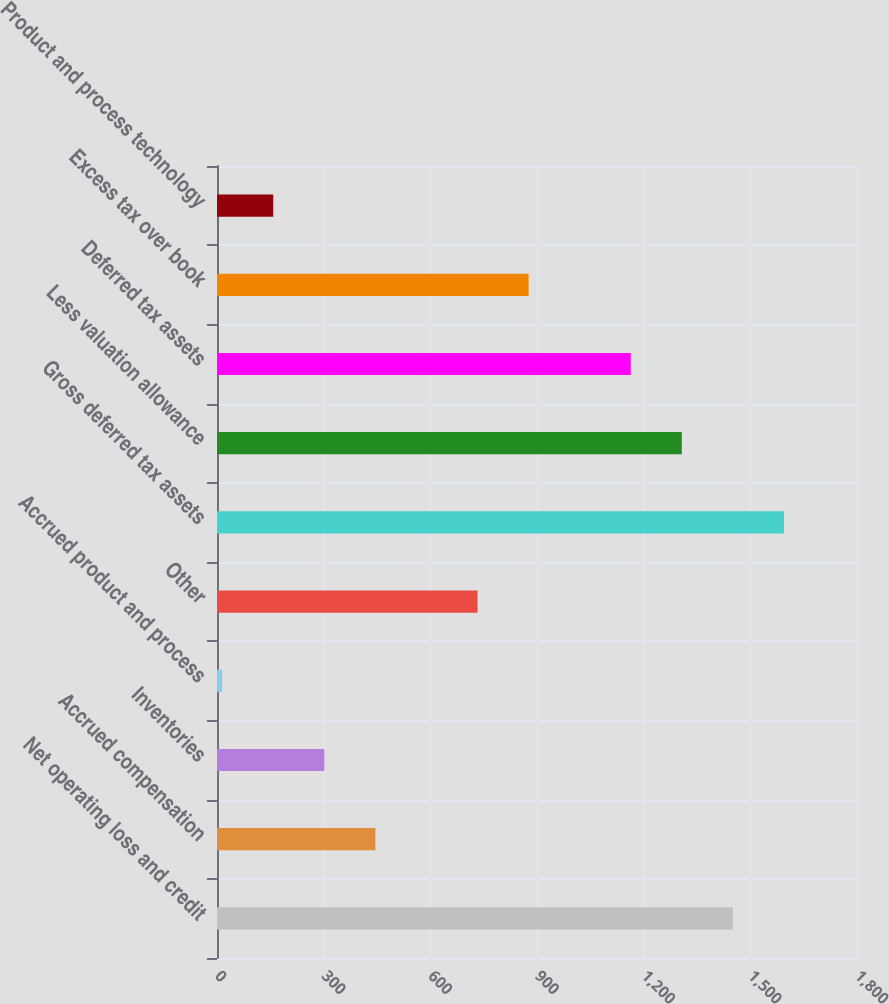Convert chart to OTSL. <chart><loc_0><loc_0><loc_500><loc_500><bar_chart><fcel>Net operating loss and credit<fcel>Accrued compensation<fcel>Inventories<fcel>Accrued product and process<fcel>Other<fcel>Gross deferred tax assets<fcel>Less valuation allowance<fcel>Deferred tax assets<fcel>Excess tax over book<fcel>Product and process technology<nl><fcel>1450.9<fcel>445.49<fcel>301.86<fcel>14.6<fcel>732.75<fcel>1594.53<fcel>1307.27<fcel>1163.64<fcel>876.38<fcel>158.23<nl></chart> 